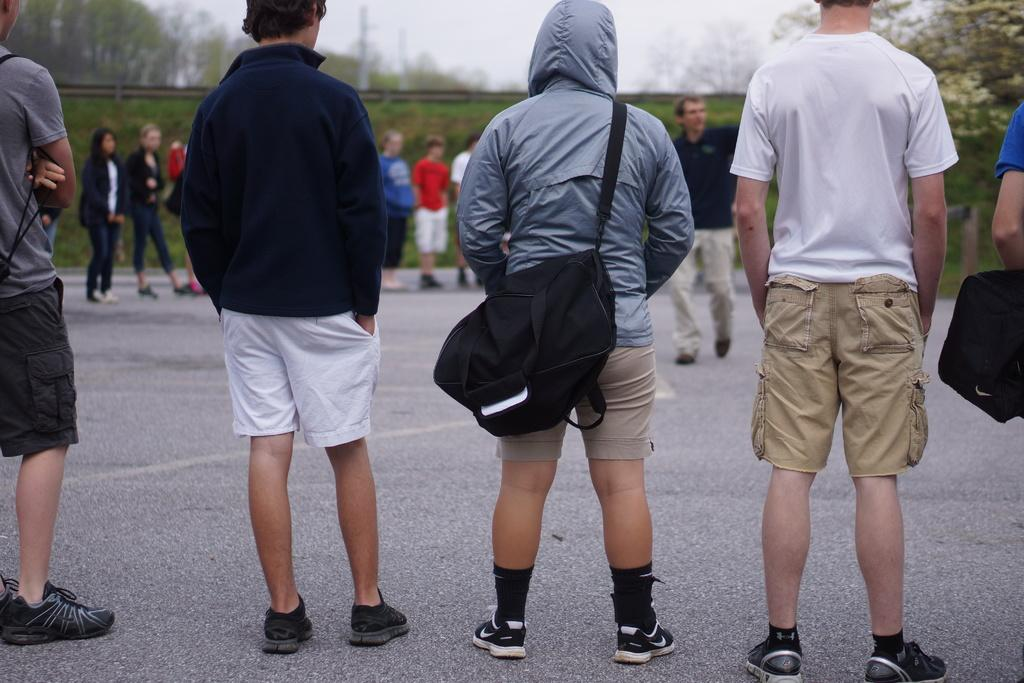What is happening at the bottom of the image? There is a road at the bottom of the image. What can be seen in the background of the image? There are trees and green grass in the background of the image. What is the main subject of the image? The main subject of the image is the many people standing on the road. What type of appliance can be seen in the image? There is no appliance present in the image. What color is the mitten that the person in the image is wearing? There is no mitten present in the image. 